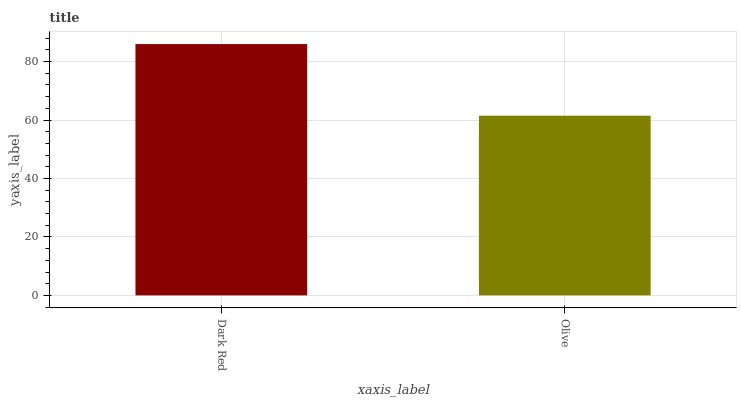Is Olive the minimum?
Answer yes or no. Yes. Is Dark Red the maximum?
Answer yes or no. Yes. Is Olive the maximum?
Answer yes or no. No. Is Dark Red greater than Olive?
Answer yes or no. Yes. Is Olive less than Dark Red?
Answer yes or no. Yes. Is Olive greater than Dark Red?
Answer yes or no. No. Is Dark Red less than Olive?
Answer yes or no. No. Is Dark Red the high median?
Answer yes or no. Yes. Is Olive the low median?
Answer yes or no. Yes. Is Olive the high median?
Answer yes or no. No. Is Dark Red the low median?
Answer yes or no. No. 